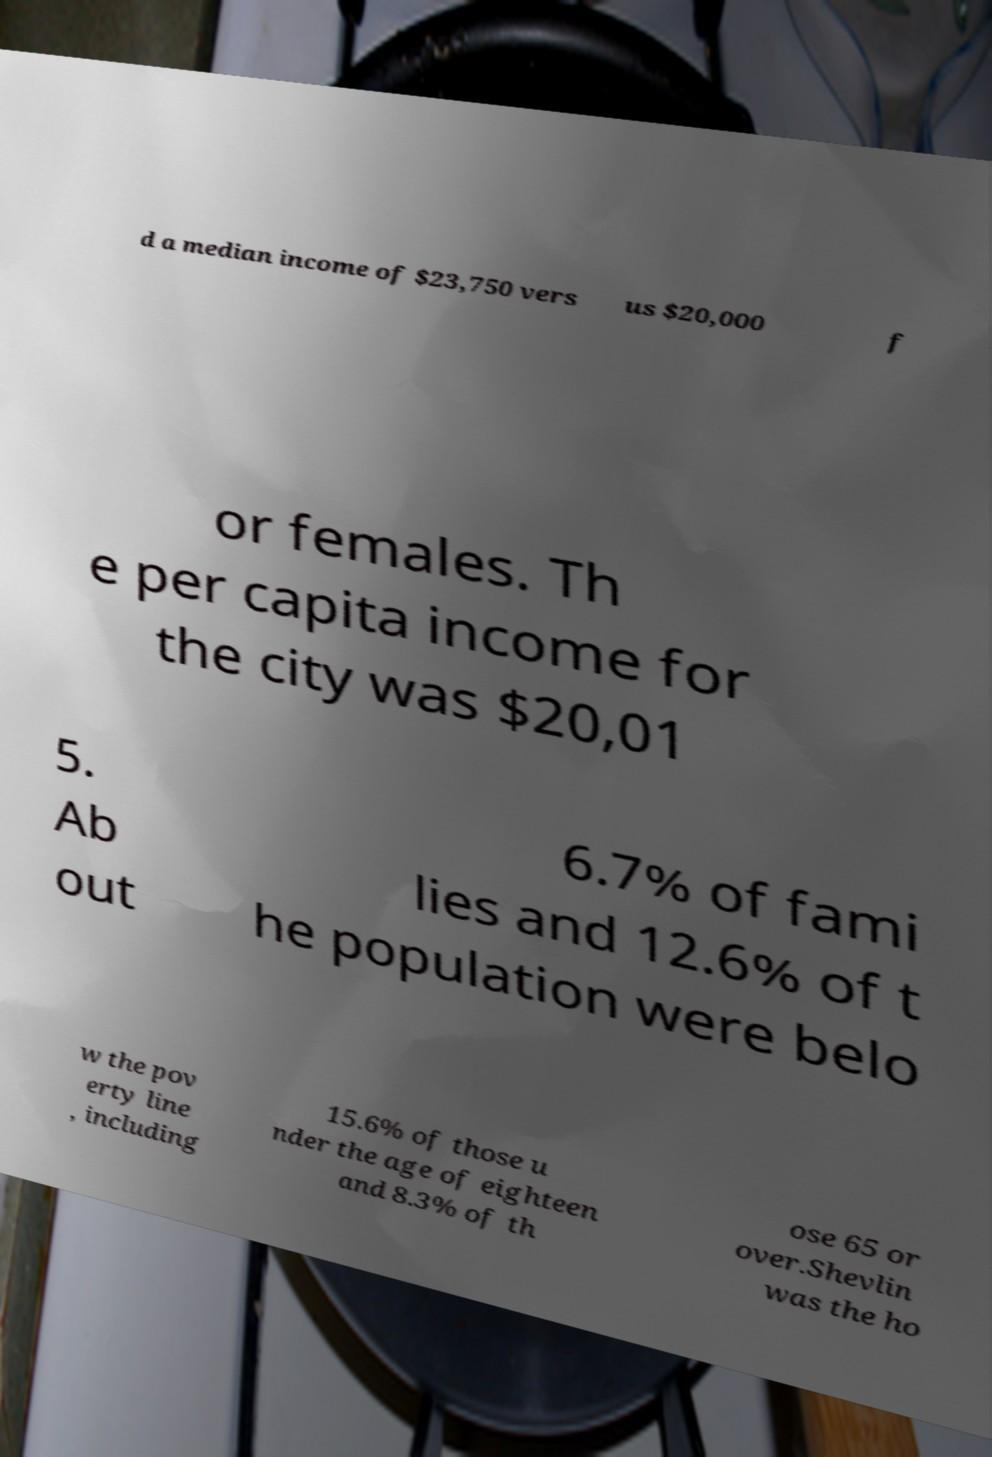What messages or text are displayed in this image? I need them in a readable, typed format. d a median income of $23,750 vers us $20,000 f or females. Th e per capita income for the city was $20,01 5. Ab out 6.7% of fami lies and 12.6% of t he population were belo w the pov erty line , including 15.6% of those u nder the age of eighteen and 8.3% of th ose 65 or over.Shevlin was the ho 